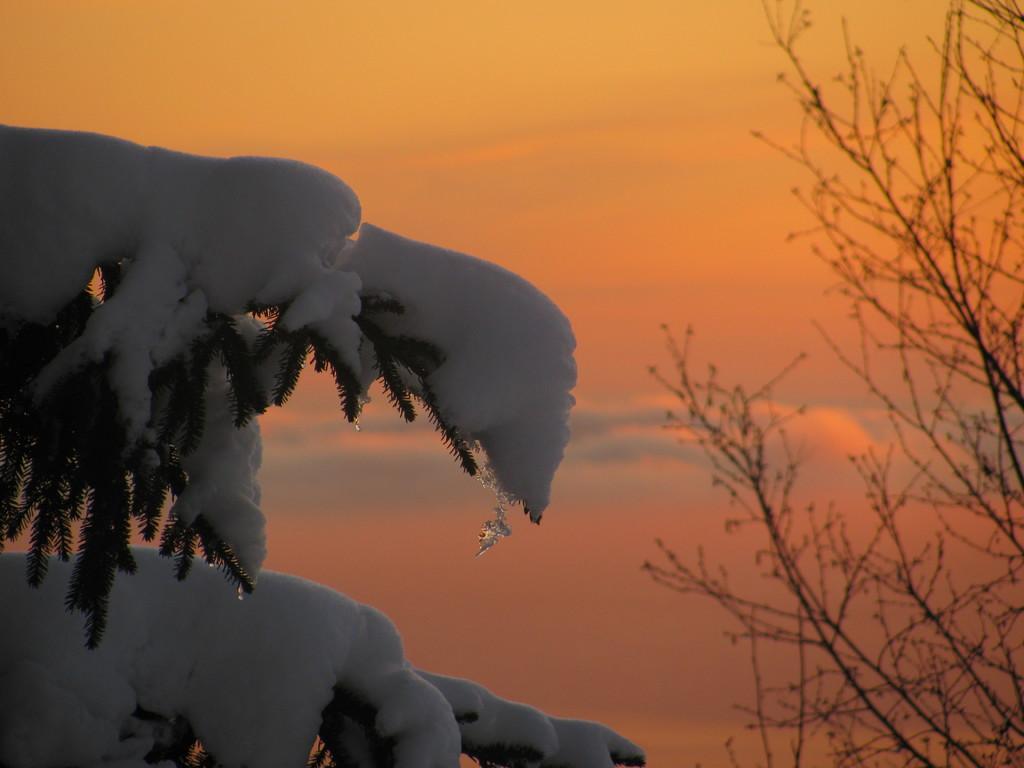Can you describe this image briefly? In this picture there are trees and there is snow on the tree. At the top there is sky and there are clouds. 